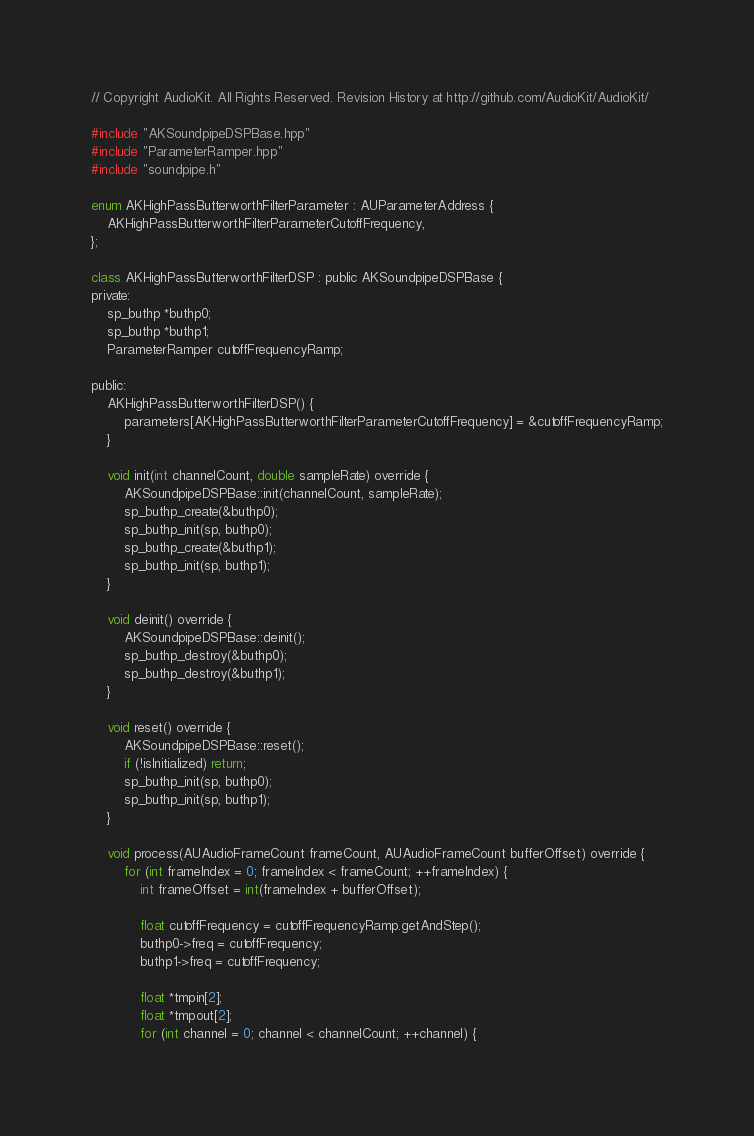Convert code to text. <code><loc_0><loc_0><loc_500><loc_500><_ObjectiveC_>// Copyright AudioKit. All Rights Reserved. Revision History at http://github.com/AudioKit/AudioKit/

#include "AKSoundpipeDSPBase.hpp"
#include "ParameterRamper.hpp"
#include "soundpipe.h"

enum AKHighPassButterworthFilterParameter : AUParameterAddress {
    AKHighPassButterworthFilterParameterCutoffFrequency,
};

class AKHighPassButterworthFilterDSP : public AKSoundpipeDSPBase {
private:
    sp_buthp *buthp0;
    sp_buthp *buthp1;
    ParameterRamper cutoffFrequencyRamp;

public:
    AKHighPassButterworthFilterDSP() {
        parameters[AKHighPassButterworthFilterParameterCutoffFrequency] = &cutoffFrequencyRamp;
    }

    void init(int channelCount, double sampleRate) override {
        AKSoundpipeDSPBase::init(channelCount, sampleRate);
        sp_buthp_create(&buthp0);
        sp_buthp_init(sp, buthp0);
        sp_buthp_create(&buthp1);
        sp_buthp_init(sp, buthp1);
    }

    void deinit() override {
        AKSoundpipeDSPBase::deinit();
        sp_buthp_destroy(&buthp0);
        sp_buthp_destroy(&buthp1);
    }

    void reset() override {
        AKSoundpipeDSPBase::reset();
        if (!isInitialized) return;
        sp_buthp_init(sp, buthp0);
        sp_buthp_init(sp, buthp1);
    }

    void process(AUAudioFrameCount frameCount, AUAudioFrameCount bufferOffset) override {
        for (int frameIndex = 0; frameIndex < frameCount; ++frameIndex) {
            int frameOffset = int(frameIndex + bufferOffset);

            float cutoffFrequency = cutoffFrequencyRamp.getAndStep();
            buthp0->freq = cutoffFrequency;
            buthp1->freq = cutoffFrequency;

            float *tmpin[2];
            float *tmpout[2];
            for (int channel = 0; channel < channelCount; ++channel) {</code> 